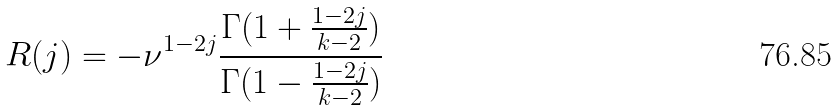Convert formula to latex. <formula><loc_0><loc_0><loc_500><loc_500>R ( j ) = - \nu ^ { 1 - 2 j } \frac { \Gamma ( 1 + \frac { 1 - 2 j } { k - 2 } ) } { \Gamma ( 1 - \frac { 1 - 2 j } { k - 2 } ) }</formula> 